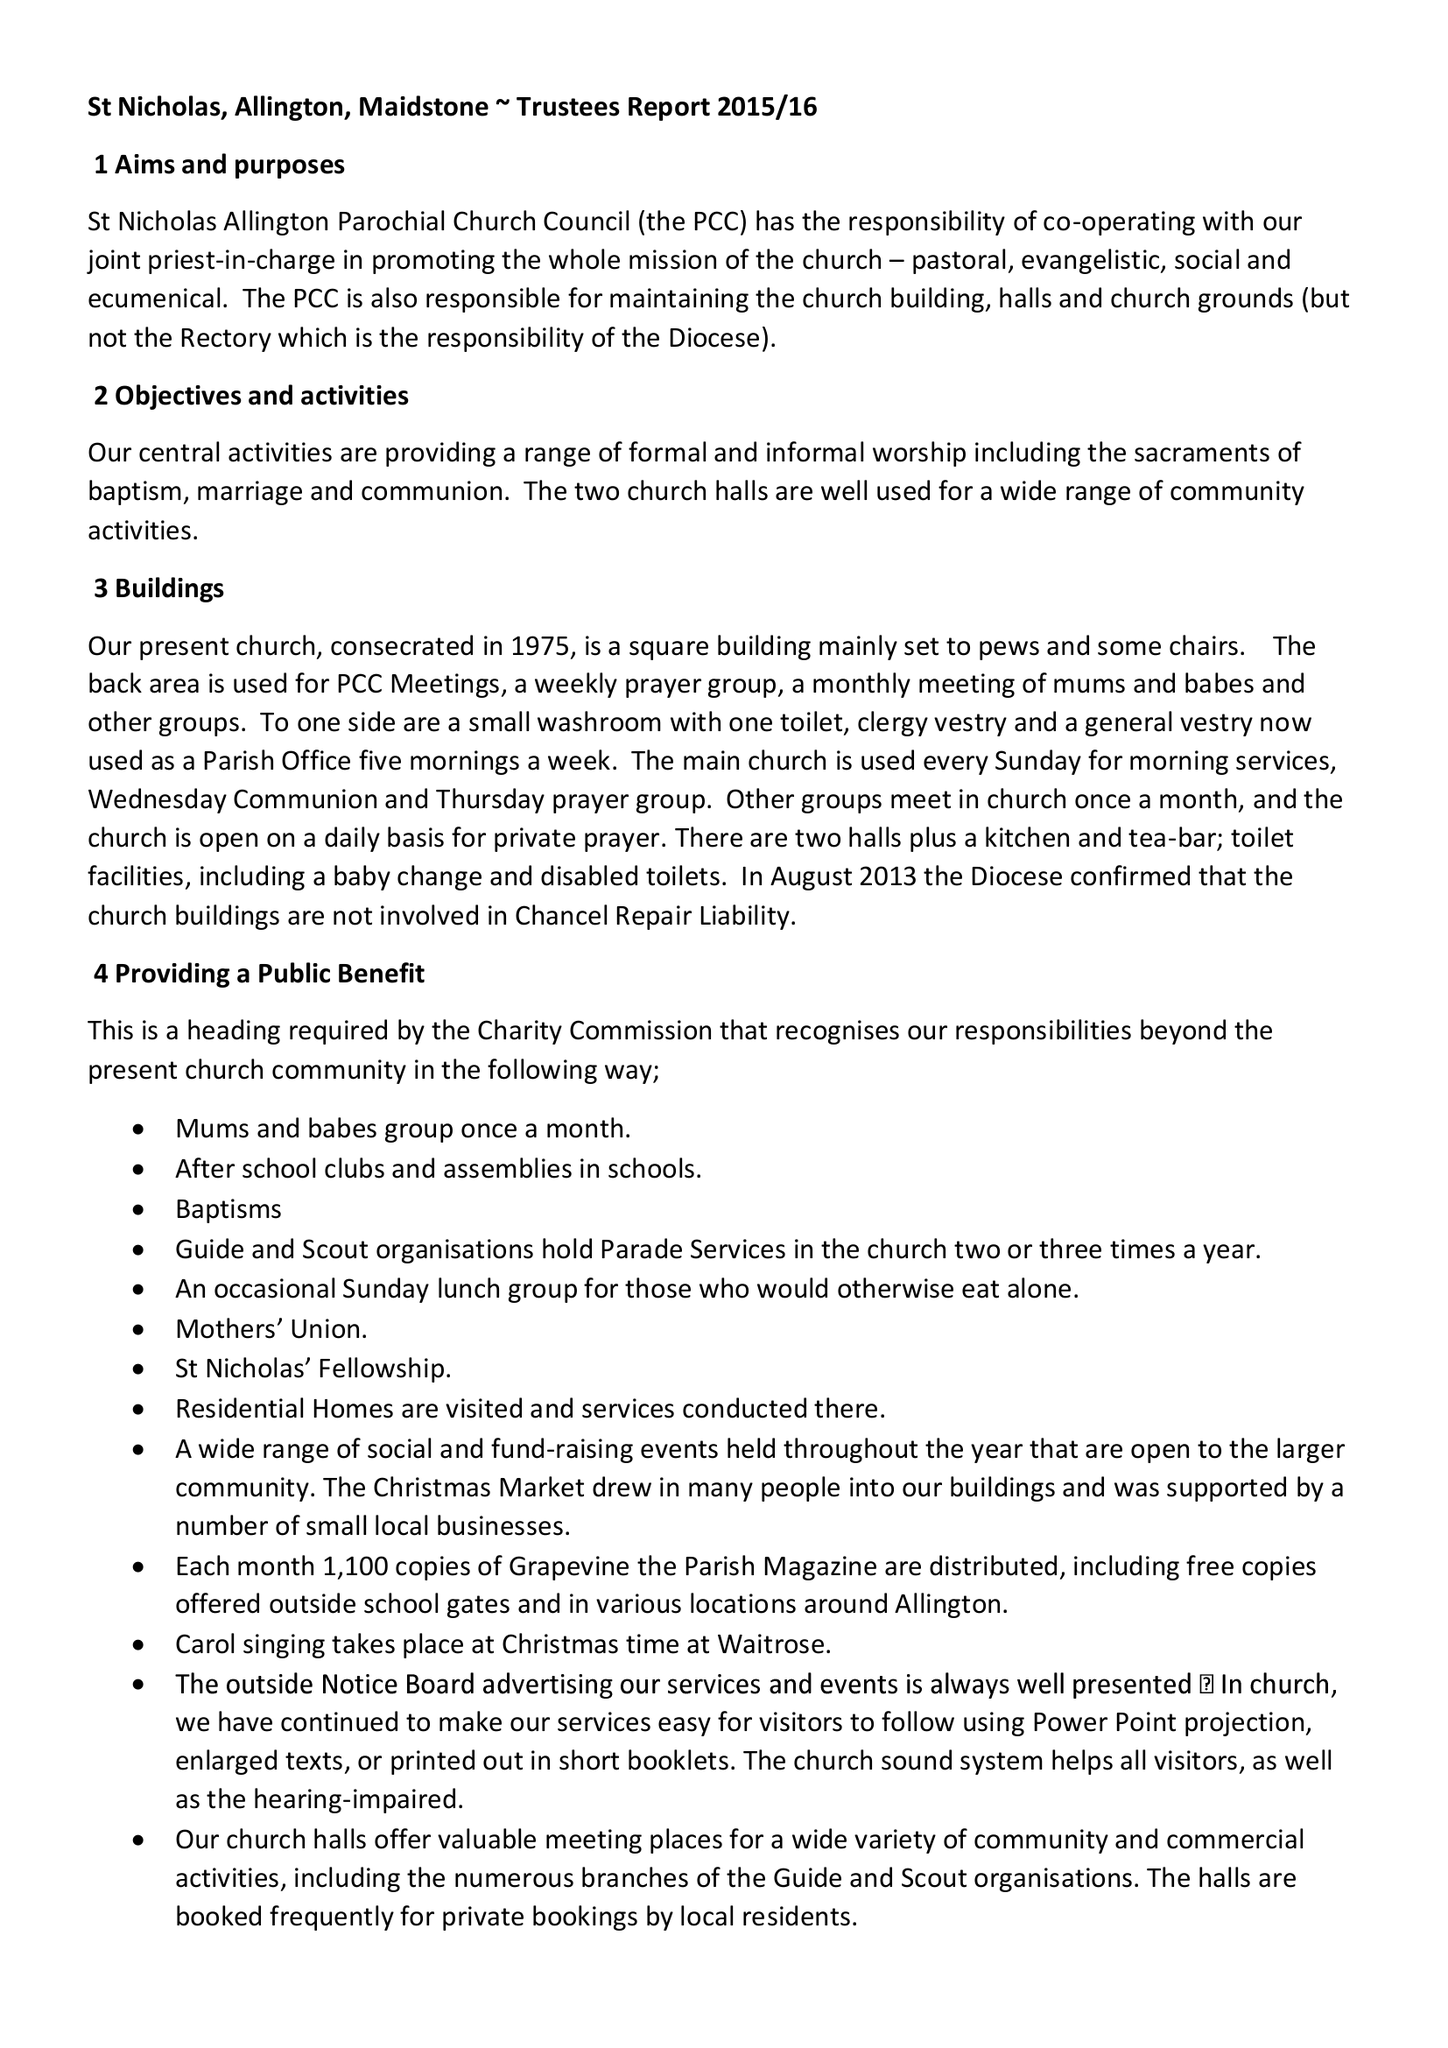What is the value for the report_date?
Answer the question using a single word or phrase. 2015-12-31 